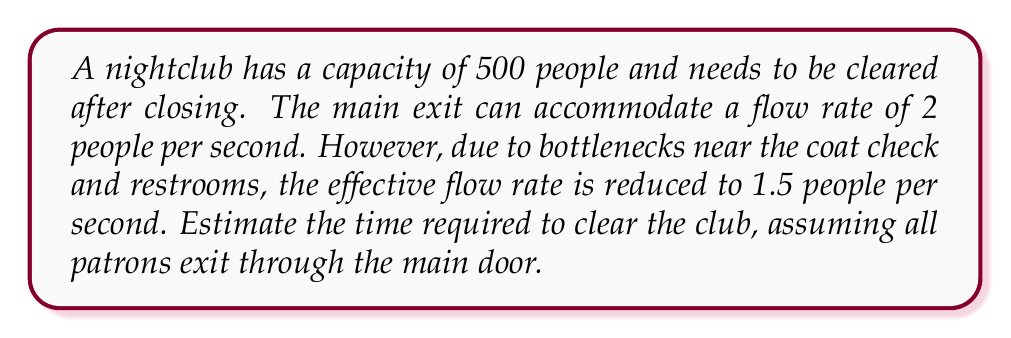Provide a solution to this math problem. To solve this problem, we'll use the following approach:

1. Identify the given information:
   - Club capacity: 500 people
   - Effective flow rate: 1.5 people/second

2. Set up the equation:
   Let $t$ be the time required to clear the club.
   $$\text{Number of people} = \text{Flow rate} \times \text{Time}$$
   $$500 = 1.5 \times t$$

3. Solve for $t$:
   $$t = \frac{500}{1.5}$$
   $$t = \frac{1000}{3} \approx 333.33 \text{ seconds}$$

4. Convert seconds to minutes:
   $$333.33 \text{ seconds} \times \frac{1 \text{ minute}}{60 \text{ seconds}} \approx 5.56 \text{ minutes}$$

5. Round up to the nearest minute for a practical estimate:
   $$5.56 \text{ minutes} \approx 6 \text{ minutes}$$

Therefore, it would take approximately 6 minutes to clear the club after closing.
Answer: 6 minutes 